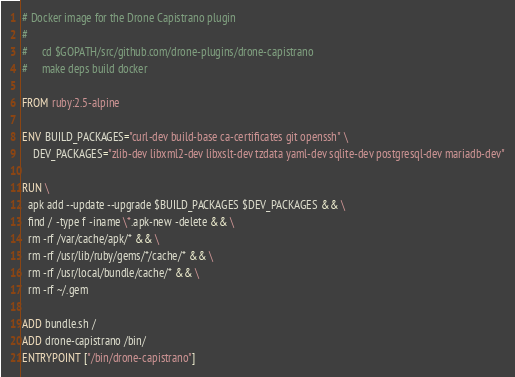<code> <loc_0><loc_0><loc_500><loc_500><_Dockerfile_># Docker image for the Drone Capistrano plugin
#
#     cd $GOPATH/src/github.com/drone-plugins/drone-capistrano
#     make deps build docker

FROM ruby:2.5-alpine

ENV BUILD_PACKAGES="curl-dev build-base ca-certificates git openssh" \
    DEV_PACKAGES="zlib-dev libxml2-dev libxslt-dev tzdata yaml-dev sqlite-dev postgresql-dev mariadb-dev"

RUN \
  apk add --update --upgrade $BUILD_PACKAGES $DEV_PACKAGES && \
  find / -type f -iname \*.apk-new -delete && \
  rm -rf /var/cache/apk/* && \
  rm -rf /usr/lib/ruby/gems/*/cache/* && \
  rm -rf /usr/local/bundle/cache/* && \
  rm -rf ~/.gem

ADD bundle.sh /
ADD drone-capistrano /bin/
ENTRYPOINT ["/bin/drone-capistrano"]
</code> 